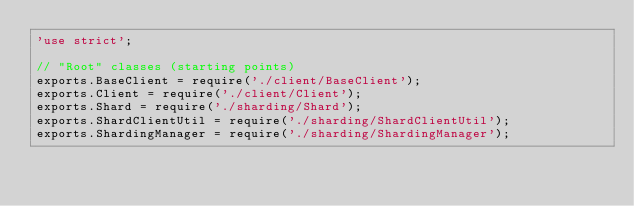<code> <loc_0><loc_0><loc_500><loc_500><_JavaScript_>'use strict';

// "Root" classes (starting points)
exports.BaseClient = require('./client/BaseClient');
exports.Client = require('./client/Client');
exports.Shard = require('./sharding/Shard');
exports.ShardClientUtil = require('./sharding/ShardClientUtil');
exports.ShardingManager = require('./sharding/ShardingManager');</code> 